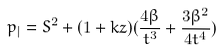Convert formula to latex. <formula><loc_0><loc_0><loc_500><loc_500>p _ { | } = S ^ { 2 } + ( 1 + k z ) ( \frac { 4 { \beta } } { t ^ { 3 } } + \frac { 3 { \beta } ^ { 2 } } { 4 t ^ { 4 } } )</formula> 